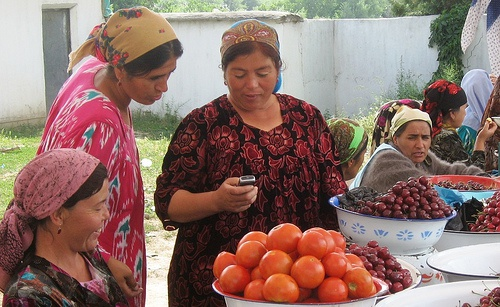Describe the objects in this image and their specific colors. I can see people in lightgray, black, maroon, and brown tones, people in lightgray, brown, and maroon tones, people in lightgray, brown, black, and maroon tones, bowl in lightgray, darkgray, maroon, black, and gray tones, and people in lightgray, gray, and maroon tones in this image. 